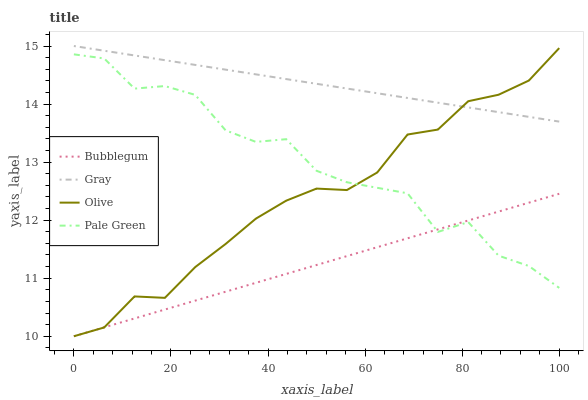Does Bubblegum have the minimum area under the curve?
Answer yes or no. Yes. Does Gray have the maximum area under the curve?
Answer yes or no. Yes. Does Pale Green have the minimum area under the curve?
Answer yes or no. No. Does Pale Green have the maximum area under the curve?
Answer yes or no. No. Is Bubblegum the smoothest?
Answer yes or no. Yes. Is Pale Green the roughest?
Answer yes or no. Yes. Is Gray the smoothest?
Answer yes or no. No. Is Gray the roughest?
Answer yes or no. No. Does Olive have the lowest value?
Answer yes or no. Yes. Does Pale Green have the lowest value?
Answer yes or no. No. Does Gray have the highest value?
Answer yes or no. Yes. Does Pale Green have the highest value?
Answer yes or no. No. Is Pale Green less than Gray?
Answer yes or no. Yes. Is Gray greater than Pale Green?
Answer yes or no. Yes. Does Pale Green intersect Olive?
Answer yes or no. Yes. Is Pale Green less than Olive?
Answer yes or no. No. Is Pale Green greater than Olive?
Answer yes or no. No. Does Pale Green intersect Gray?
Answer yes or no. No. 